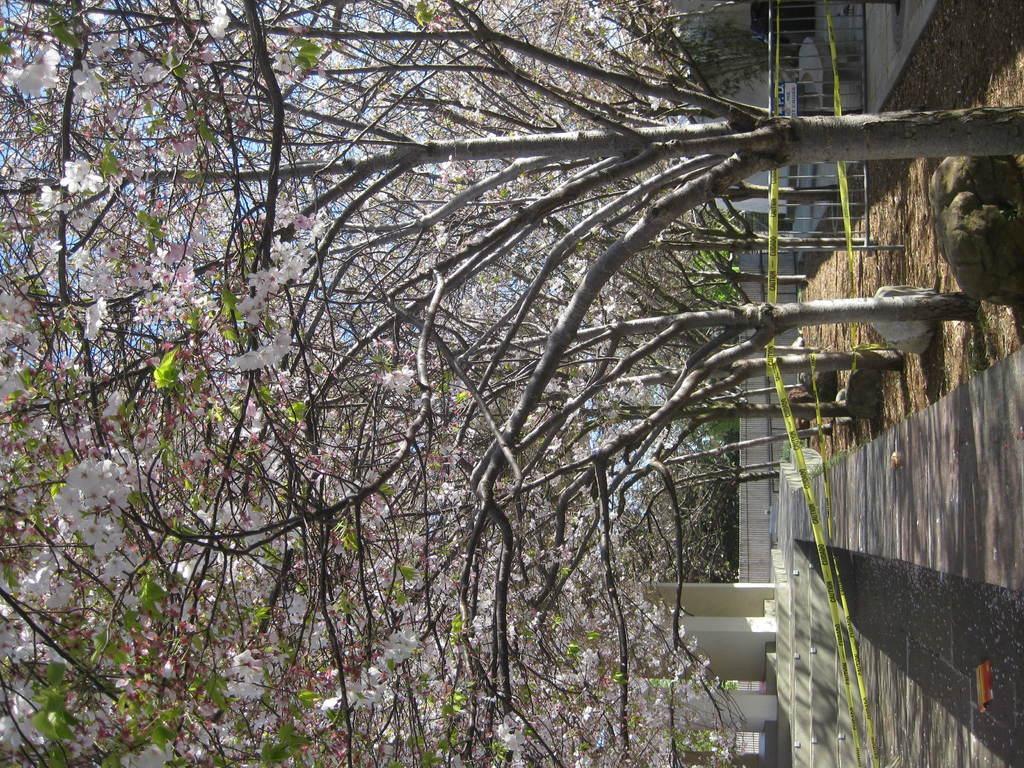In one or two sentences, can you explain what this image depicts? In the image we can see there are trees, stairs, pillars and a building, this is a soil, stones and police lines. 